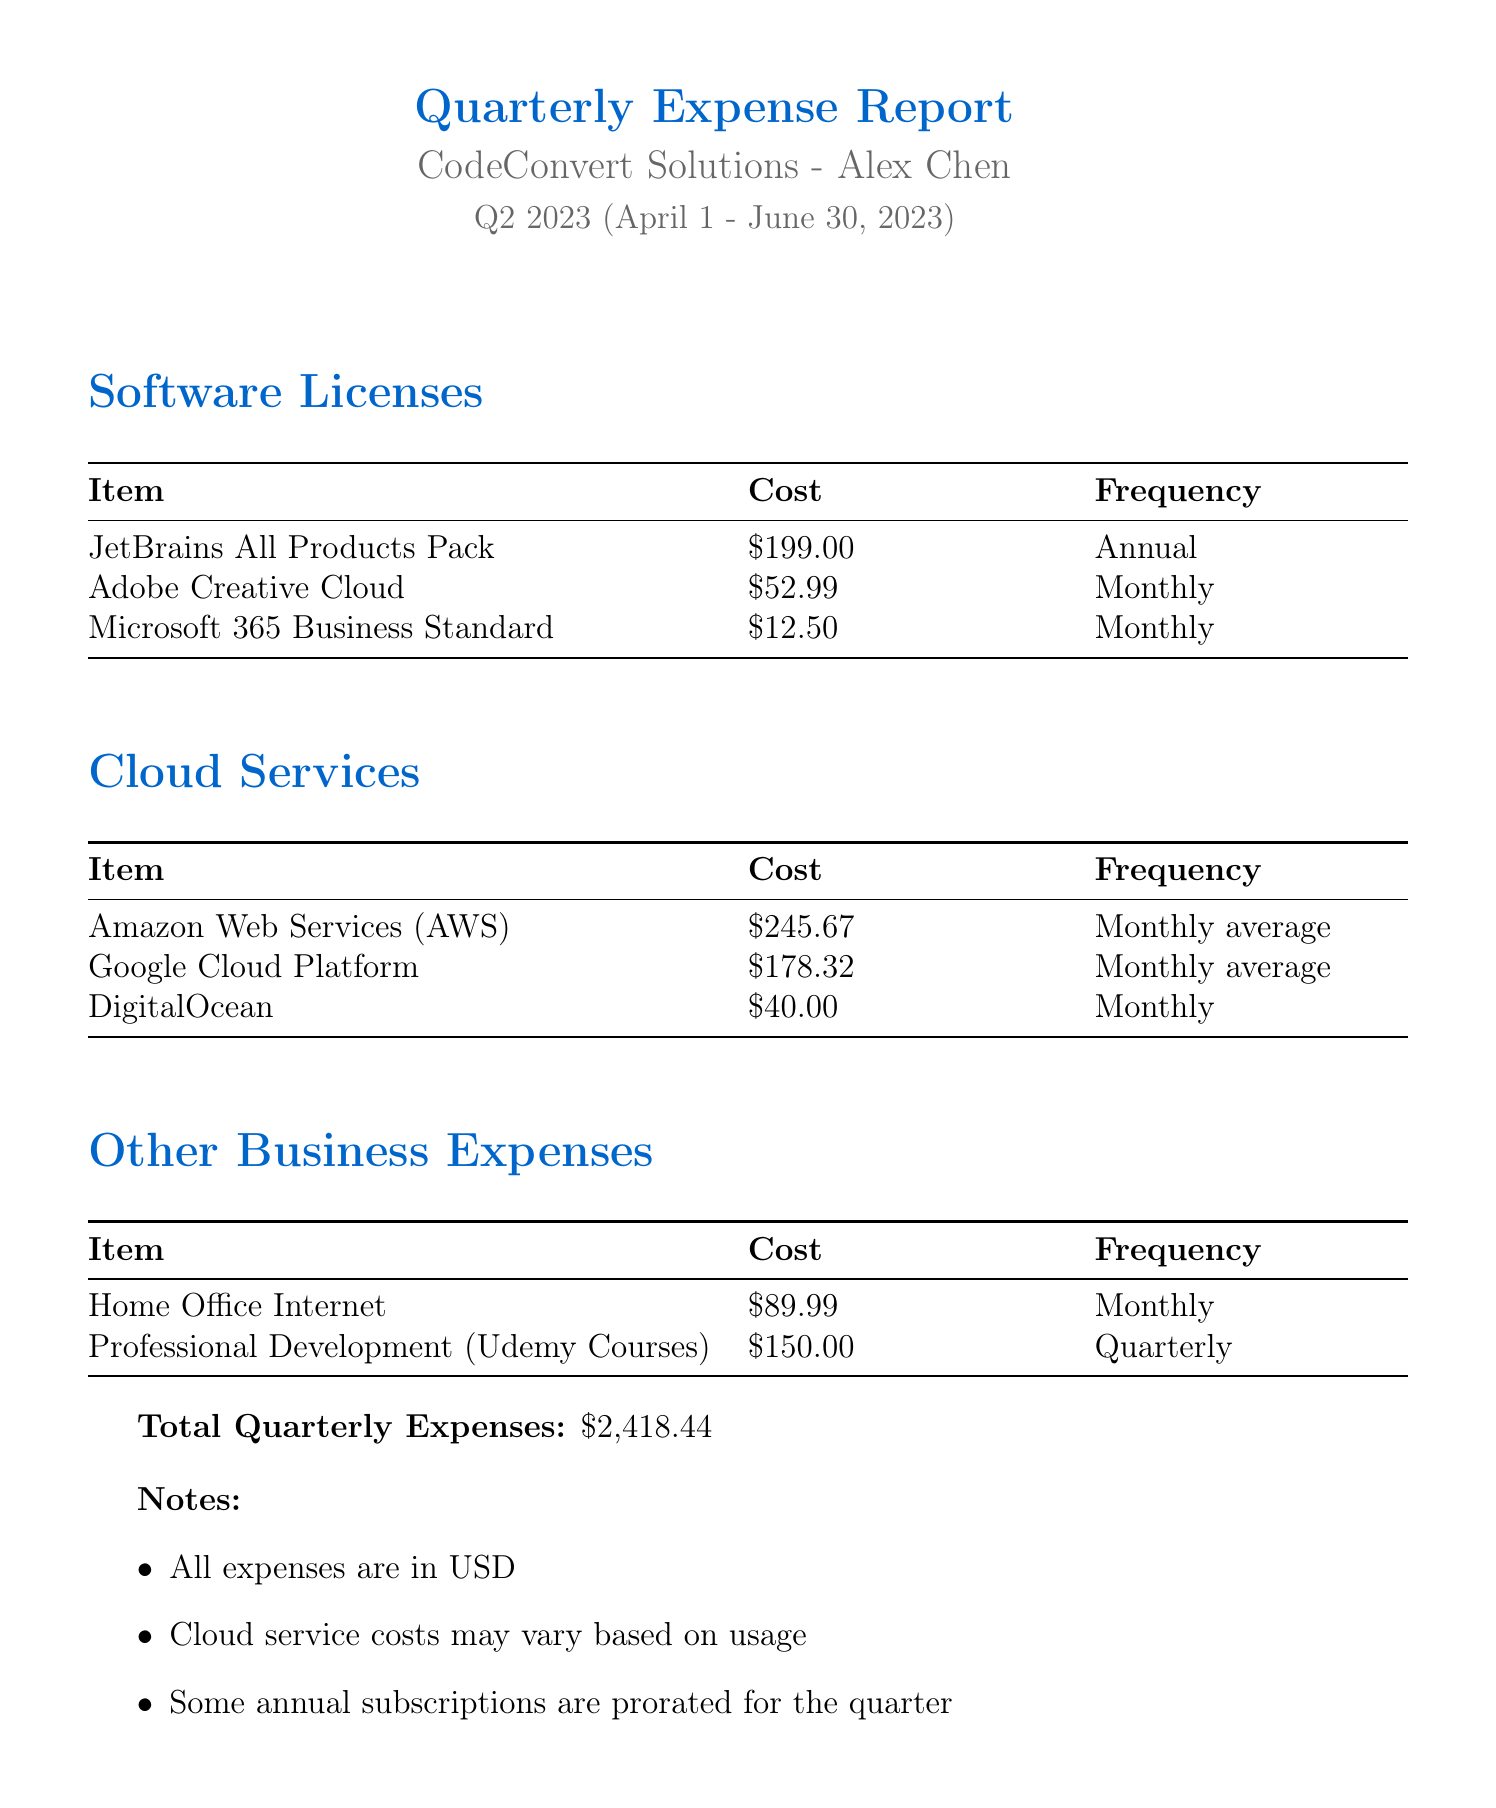What is the document title? The title of the document is stated clearly at the beginning, which is "Quarterly Expense Report for Freelance Software Engineering Business".
Answer: Quarterly Expense Report for Freelance Software Engineering Business Who is the owner of the business? The owner's name is provided in the document as the person responsible for the report.
Answer: Alex Chen What is the total quarterly expense? The document summarizes expenses and clearly states the total amount at the end.
Answer: $2,418.44 How much is the cost of Adobe Creative Cloud? The cost of specific software licenses is detailed in a table, including Adobe Creative Cloud.
Answer: $52.99 Which cloud service has the highest monthly average cost? The document lists cloud services with their costs, allowing for comparison; the service with the highest cost can be determined.
Answer: Amazon Web Services (AWS) What frequency is Microsoft 365 Business Standard billed? The frequency of billing for each software license is provided in the table.
Answer: Monthly What expense is related to professional development? The document includes a category for other business expenses where professional development is listed.
Answer: Professional Development (Udemy Courses) How often is the home office internet expense incurred? The frequency of the home office internet expense is specified in the expenses section of the document.
Answer: Monthly 